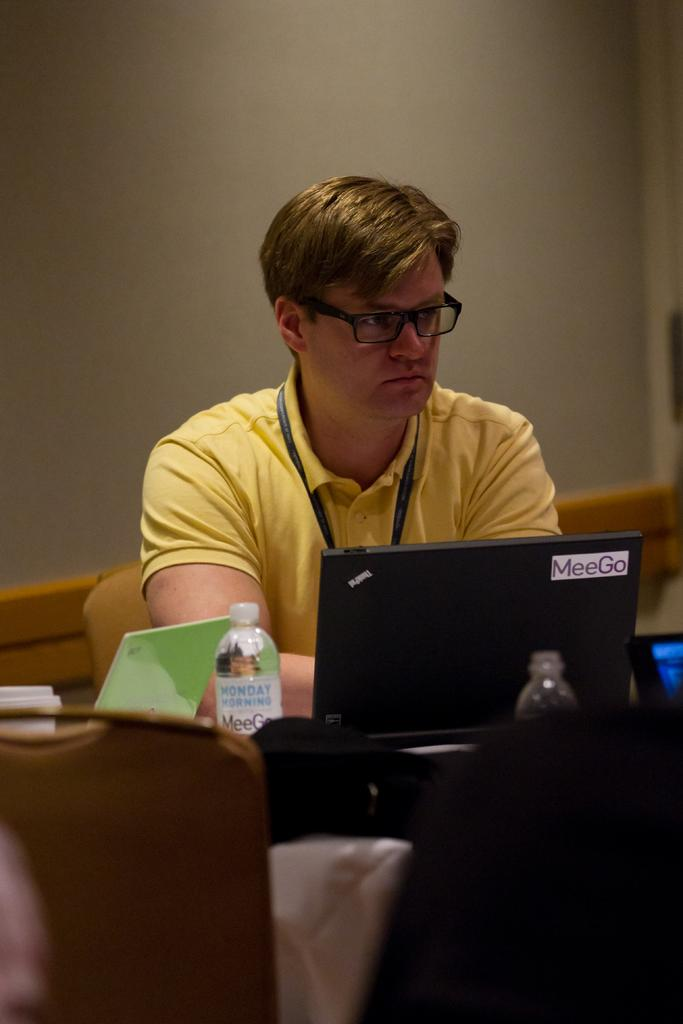What is the main subject of the image? There is a man in the image. What is the man doing in the image? The man is sitting on a chair. What can be seen on the man's face in the image? The man is wearing glasses. What color is the man's t-shirt in the image? The man is wearing a yellow t-shirt. What electronic device is present in the image? There is a laptop in the image. What is the man holding in the image? The man is holding a water bottle in the image. Are there any other items visible in the image? Yes, there are other unspecified items in the image. What type of orange is the man peeling in the image? There is no orange present in the image; the man is holding a water bottle. 